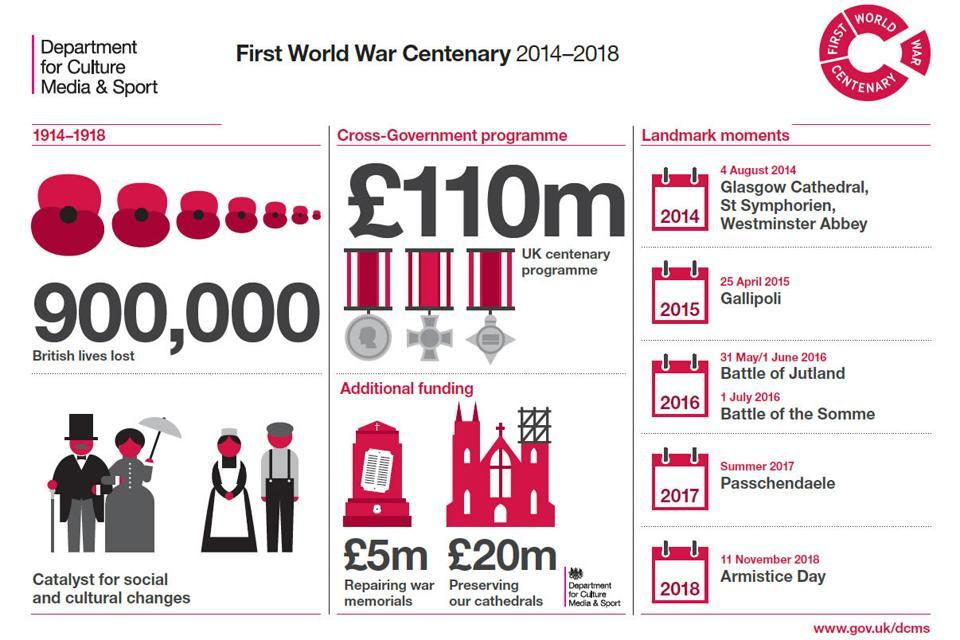For what purpose was an additional funding of 5m pounds procured?
Answer the question with a short phrase. repairing war memorials Which landmark moment happened on 11 November 2018? Armistice day 